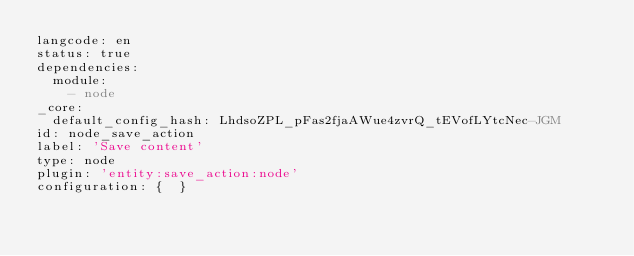Convert code to text. <code><loc_0><loc_0><loc_500><loc_500><_YAML_>langcode: en
status: true
dependencies:
  module:
    - node
_core:
  default_config_hash: LhdsoZPL_pFas2fjaAWue4zvrQ_tEVofLYtcNec-JGM
id: node_save_action
label: 'Save content'
type: node
plugin: 'entity:save_action:node'
configuration: {  }
</code> 